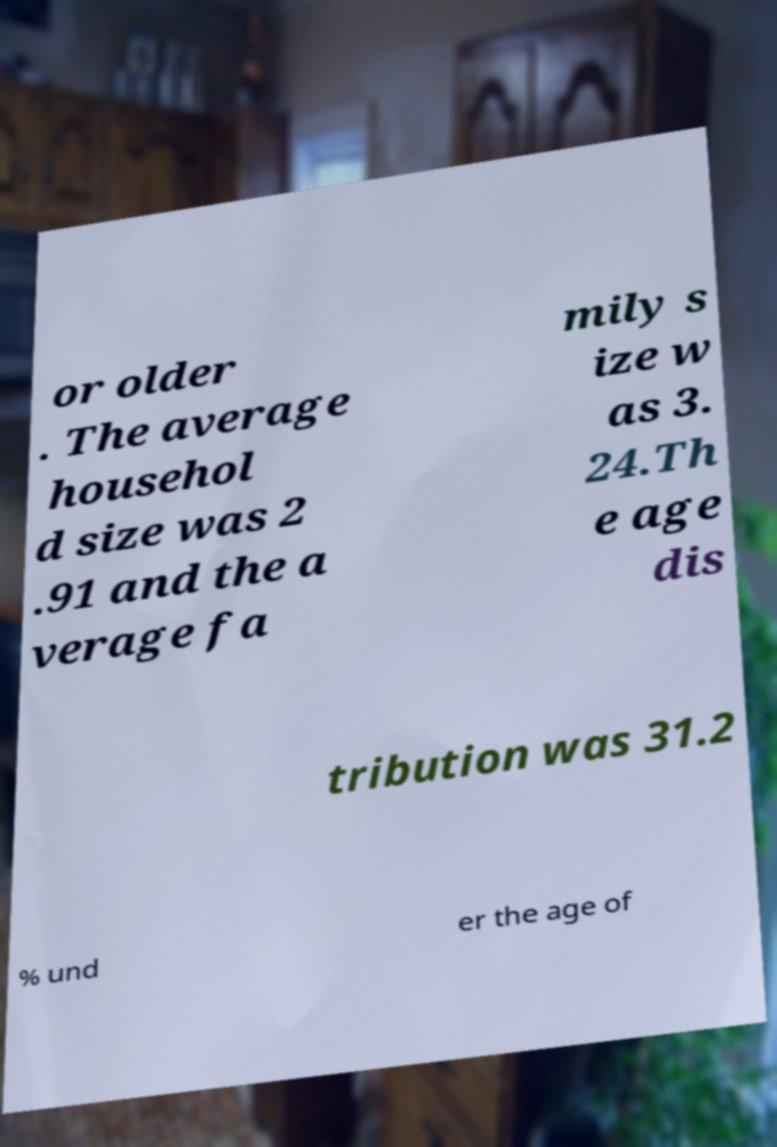I need the written content from this picture converted into text. Can you do that? or older . The average househol d size was 2 .91 and the a verage fa mily s ize w as 3. 24.Th e age dis tribution was 31.2 % und er the age of 